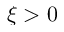Convert formula to latex. <formula><loc_0><loc_0><loc_500><loc_500>\xi > 0</formula> 